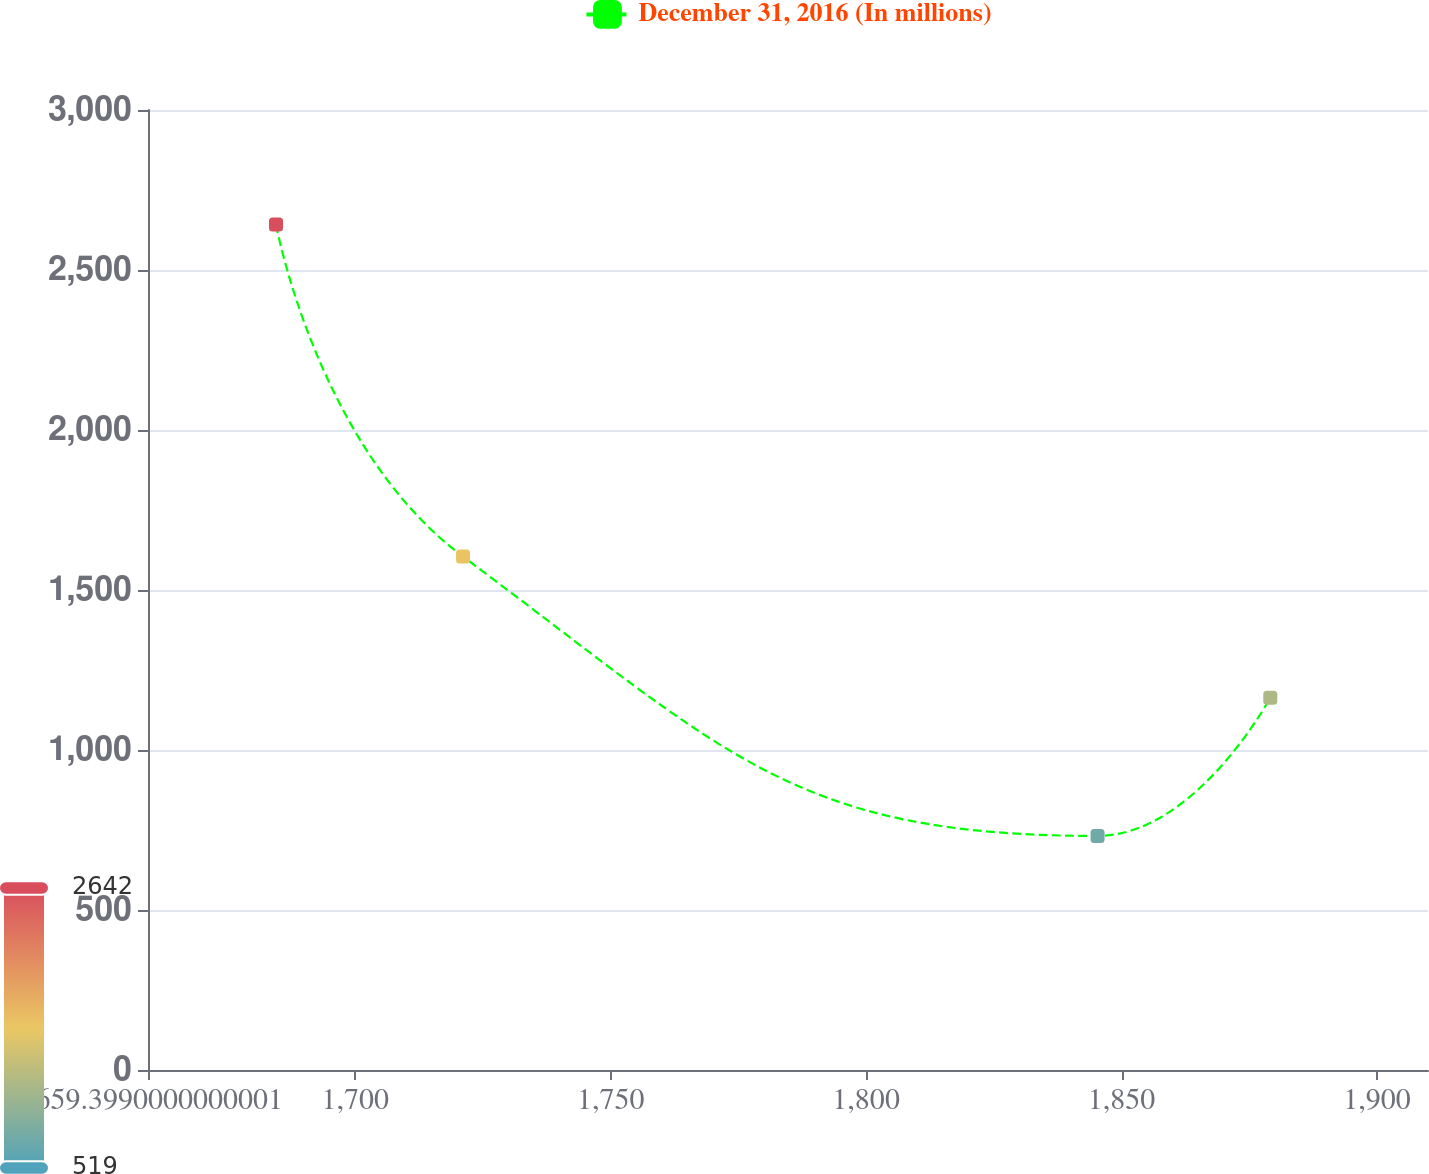Convert chart. <chart><loc_0><loc_0><loc_500><loc_500><line_chart><ecel><fcel>December 31, 2016 (In millions)<nl><fcel>1684.46<fcel>2642.2<nl><fcel>1721.08<fcel>1604.38<nl><fcel>1845.31<fcel>731.53<nl><fcel>1879.13<fcel>1163.18<nl><fcel>1935.07<fcel>519.23<nl></chart> 